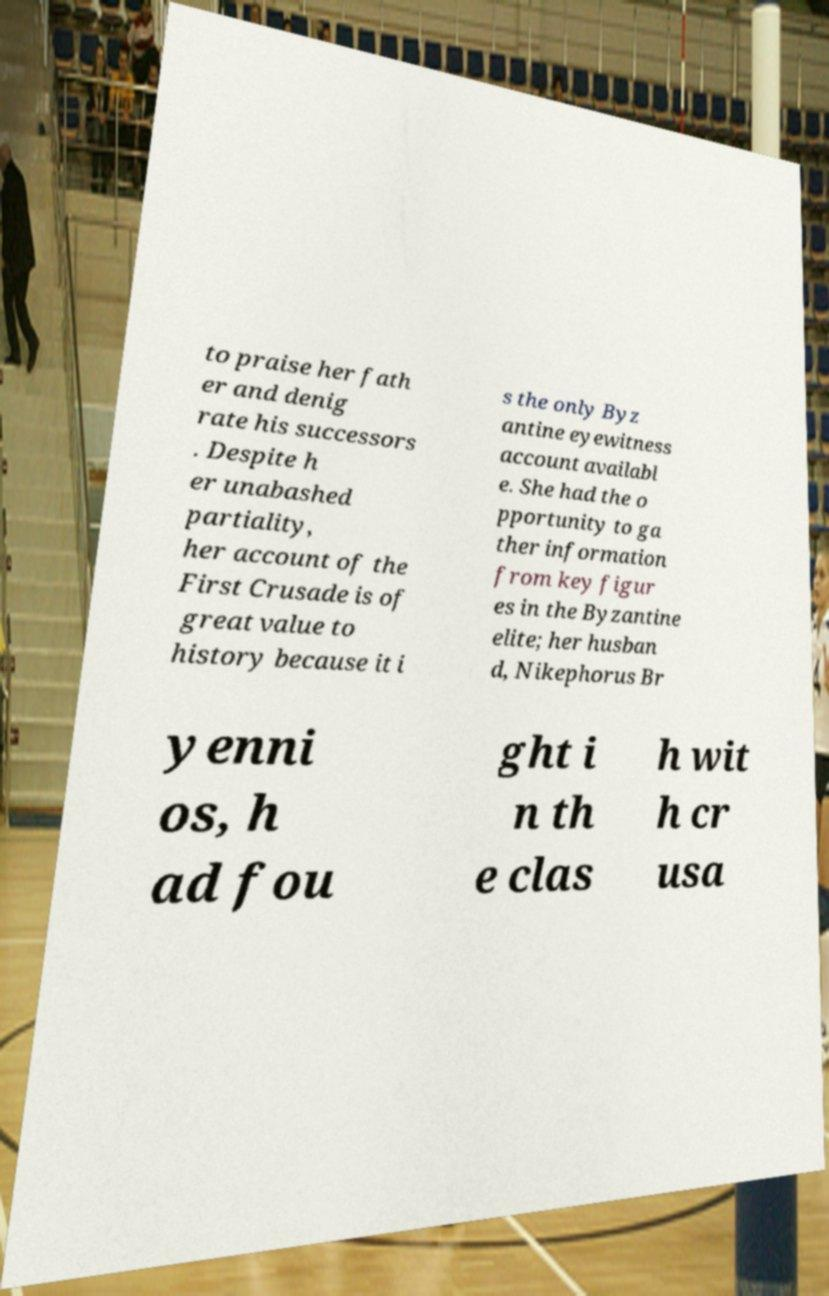Please read and relay the text visible in this image. What does it say? to praise her fath er and denig rate his successors . Despite h er unabashed partiality, her account of the First Crusade is of great value to history because it i s the only Byz antine eyewitness account availabl e. She had the o pportunity to ga ther information from key figur es in the Byzantine elite; her husban d, Nikephorus Br yenni os, h ad fou ght i n th e clas h wit h cr usa 